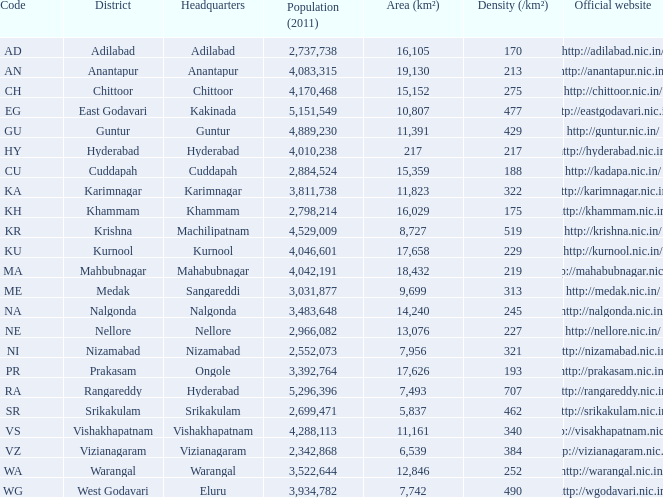What is the total of the area figures for districts with a density exceeding 462 and websites of http://krishna.nic.in/? 8727.0. 